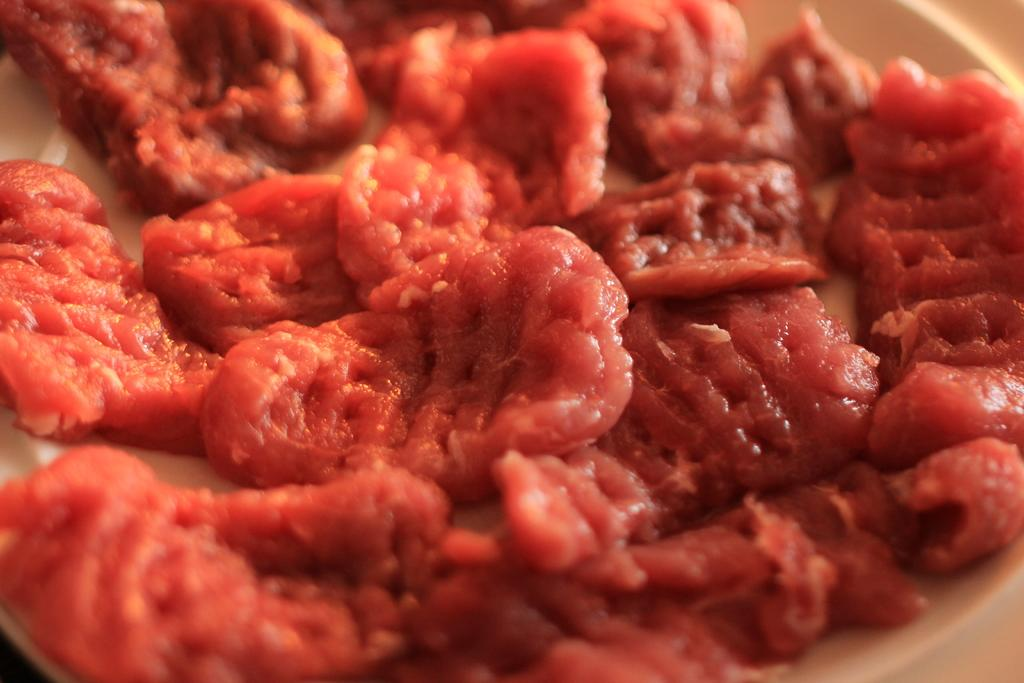What is present on the plate in the image? The plate contains pieces of meat. Can you describe the main subject of the image? The main subject of the image is a plate with pieces of meat on it. What type of lumber is being used to build the table in the image? There is no table present in the image, so it is not possible to determine the type of lumber being used. 